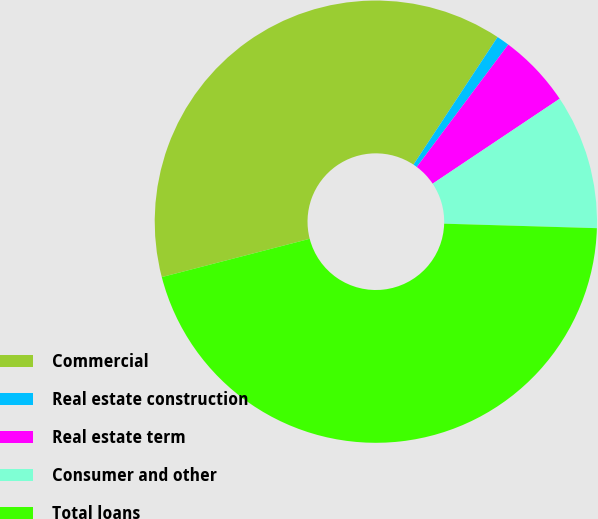Convert chart to OTSL. <chart><loc_0><loc_0><loc_500><loc_500><pie_chart><fcel>Commercial<fcel>Real estate construction<fcel>Real estate term<fcel>Consumer and other<fcel>Total loans<nl><fcel>38.31%<fcel>0.94%<fcel>5.4%<fcel>9.85%<fcel>45.5%<nl></chart> 